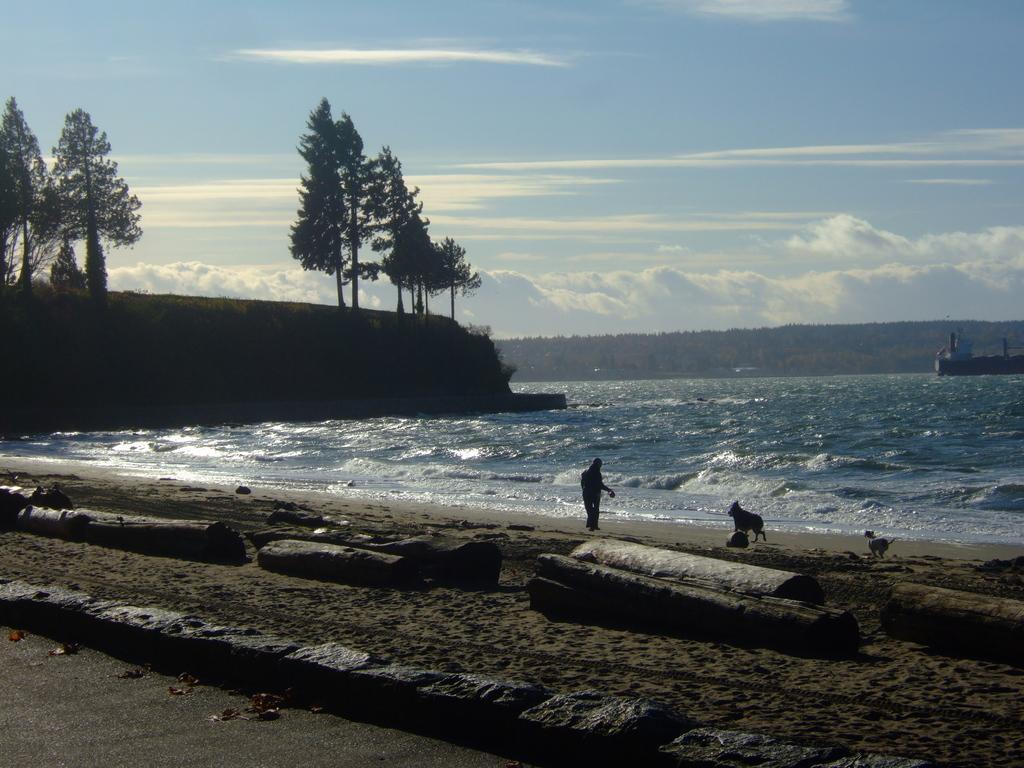In one or two sentences, can you explain what this image depicts? In this image it looks like it is a sea. At the top there is sky. Behind the sea there are hills. On the hills there are trees. At the bottom there is sand on which there are tree barks. Beside the sand there are stones. 